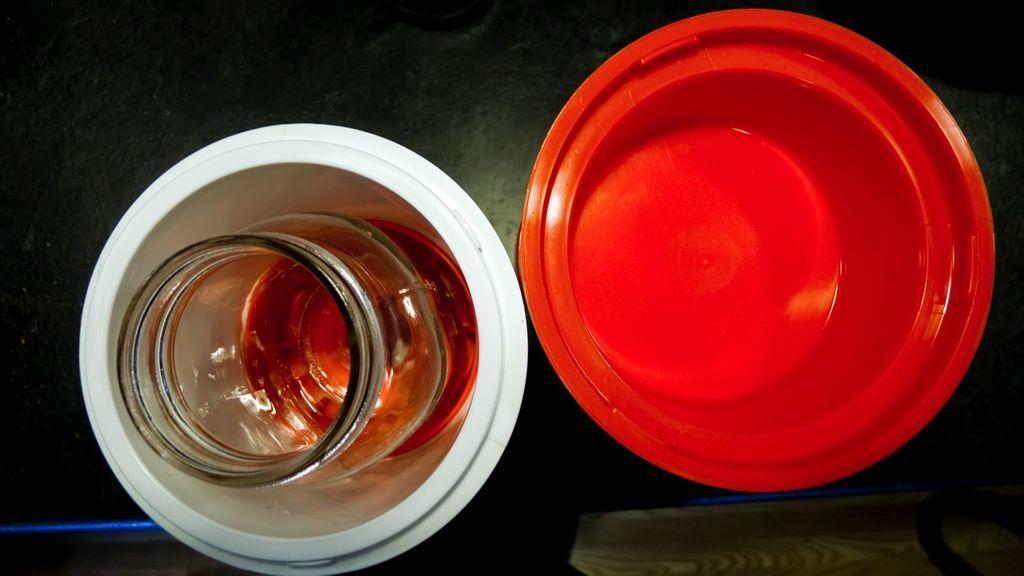In one or two sentences, can you explain what this image depicts? In this image, we can see bowls and a jar with liquid and some other objects are placed on the table. 